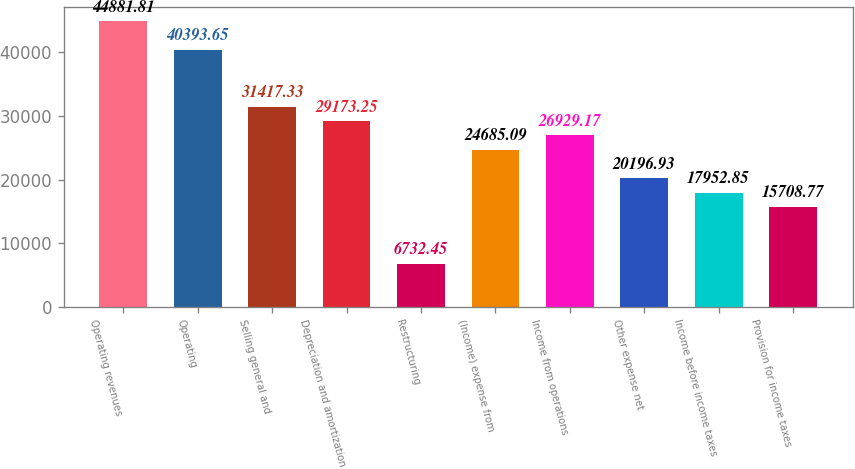Convert chart to OTSL. <chart><loc_0><loc_0><loc_500><loc_500><bar_chart><fcel>Operating revenues<fcel>Operating<fcel>Selling general and<fcel>Depreciation and amortization<fcel>Restructuring<fcel>(Income) expense from<fcel>Income from operations<fcel>Other expense net<fcel>Income before income taxes<fcel>Provision for income taxes<nl><fcel>44881.8<fcel>40393.7<fcel>31417.3<fcel>29173.2<fcel>6732.45<fcel>24685.1<fcel>26929.2<fcel>20196.9<fcel>17952.8<fcel>15708.8<nl></chart> 